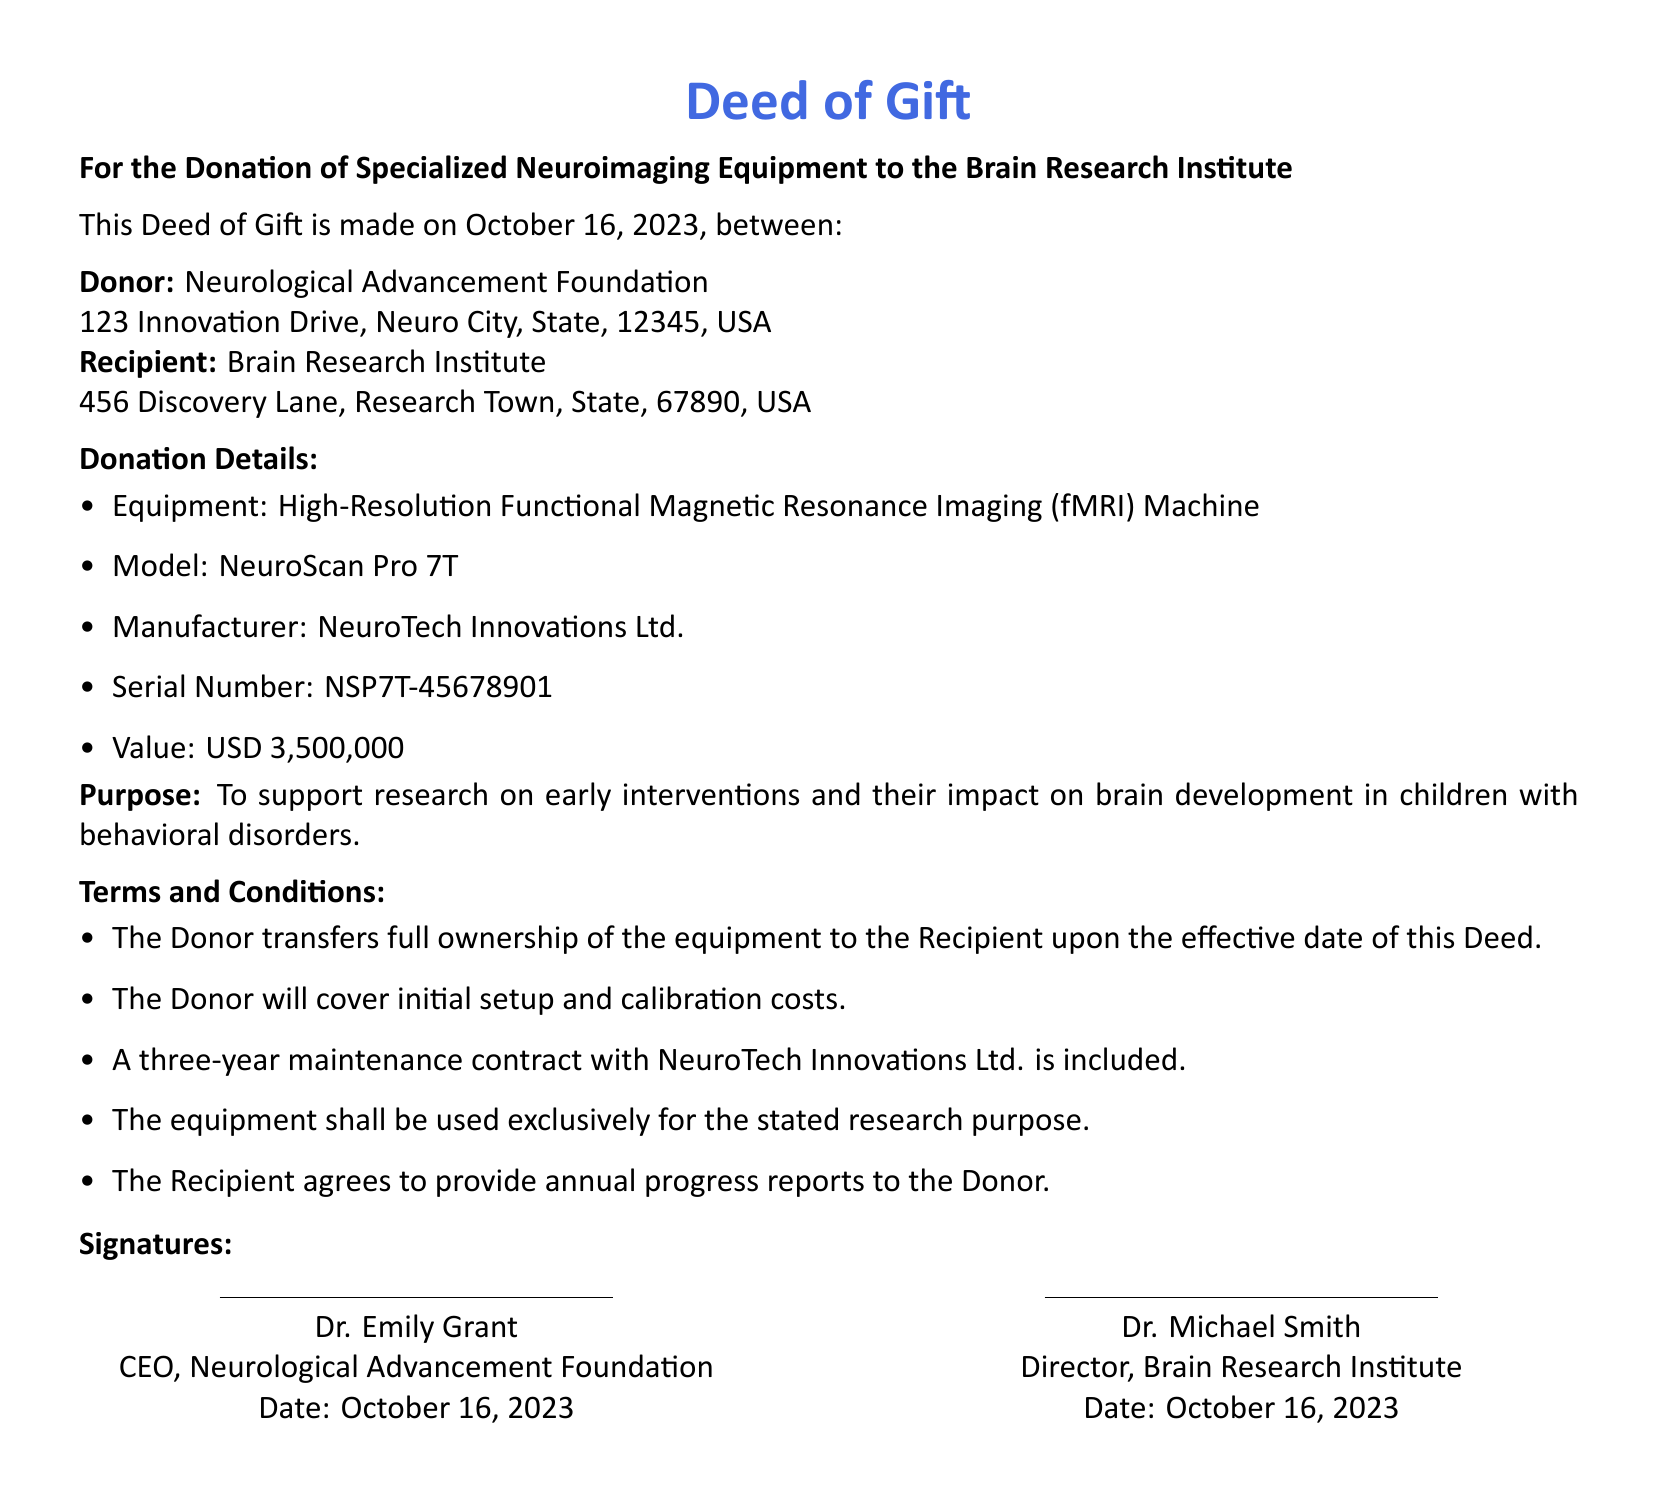What is the date of the deed? The date of the deed is stated at the beginning of the document as October 16, 2023.
Answer: October 16, 2023 Who is the donor? The document identifies the donor as the Neurological Advancement Foundation.
Answer: Neurological Advancement Foundation What type of equipment is being donated? The equipment being donated is specified in the donation details as a High-Resolution Functional Magnetic Resonance Imaging (fMRI) Machine.
Answer: High-Resolution Functional Magnetic Resonance Imaging (fMRI) Machine What is the serial number of the equipment? The serial number for the equipment is listed in the donation details as NSP7T-45678901.
Answer: NSP7T-45678901 What is the value of the donated equipment? The document states that the value of the equipment is USD 3,500,000.
Answer: USD 3,500,000 What is the purpose of the donation? The purpose of the donation is clearly described in the document to support research on early interventions and their impact on brain development in children with behavioral disorders.
Answer: To support research on early interventions and their impact on brain development in children with behavioral disorders How long is the maintenance contract included? The document specifies that there is a three-year maintenance contract with NeuroTech Innovations Ltd. included with the donation.
Answer: Three years What must the recipient provide to the donor? The terms indicate that the recipient agrees to provide annual progress reports to the donor.
Answer: Annual progress reports What is the model of the donated equipment? The model of the equipment is specified in the document as NeuroScan Pro 7T.
Answer: NeuroScan Pro 7T 